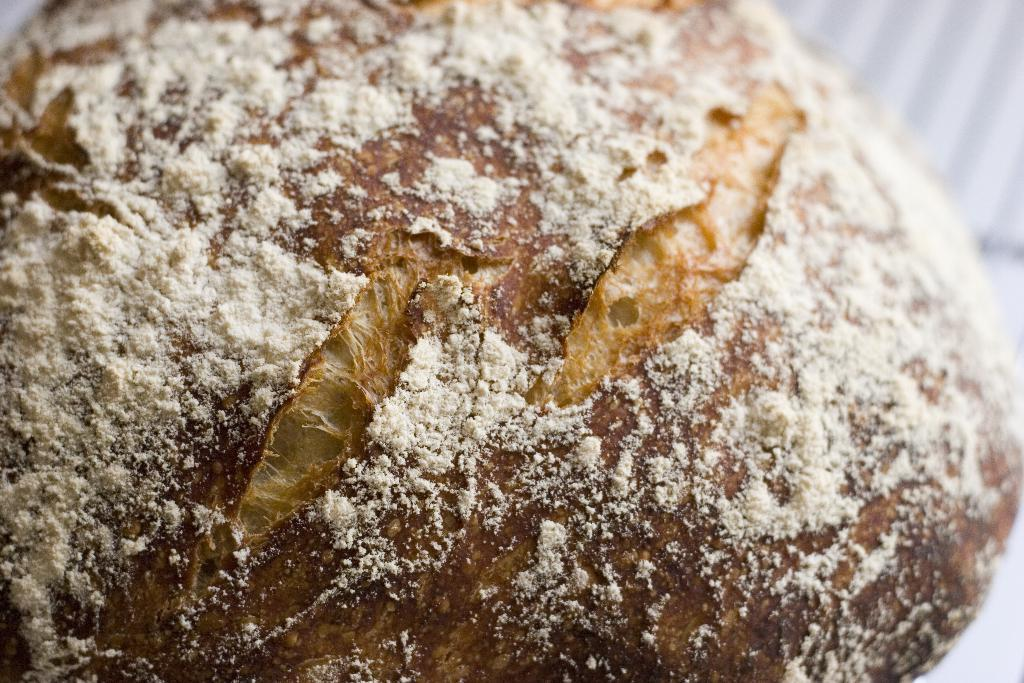What is present in the image? There is food in the image. Can you describe the food in the image? Unfortunately, the specific type of food cannot be determined from the given fact. Is there any context or setting provided for the food in the image? No, there is no additional context or setting provided for the food in the image. What type of seat can be seen in the church in the image? There is no seat or church present in the image, as the only fact provided is that there is food in the image. 